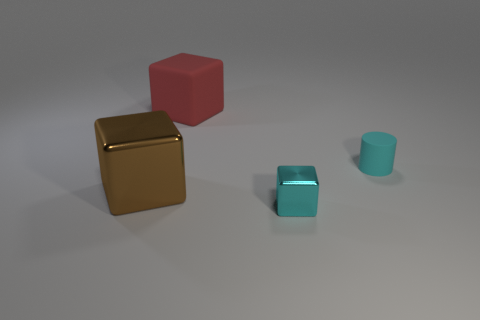Subtract all shiny blocks. How many blocks are left? 1 Add 1 tiny cylinders. How many objects exist? 5 Subtract all cyan blocks. How many blocks are left? 2 Subtract 2 cubes. How many cubes are left? 1 Subtract 0 red balls. How many objects are left? 4 Subtract all cubes. How many objects are left? 1 Subtract all brown cylinders. Subtract all purple blocks. How many cylinders are left? 1 Subtract all brown cylinders. How many green blocks are left? 0 Subtract all cyan matte cylinders. Subtract all large matte objects. How many objects are left? 2 Add 2 cyan rubber things. How many cyan rubber things are left? 3 